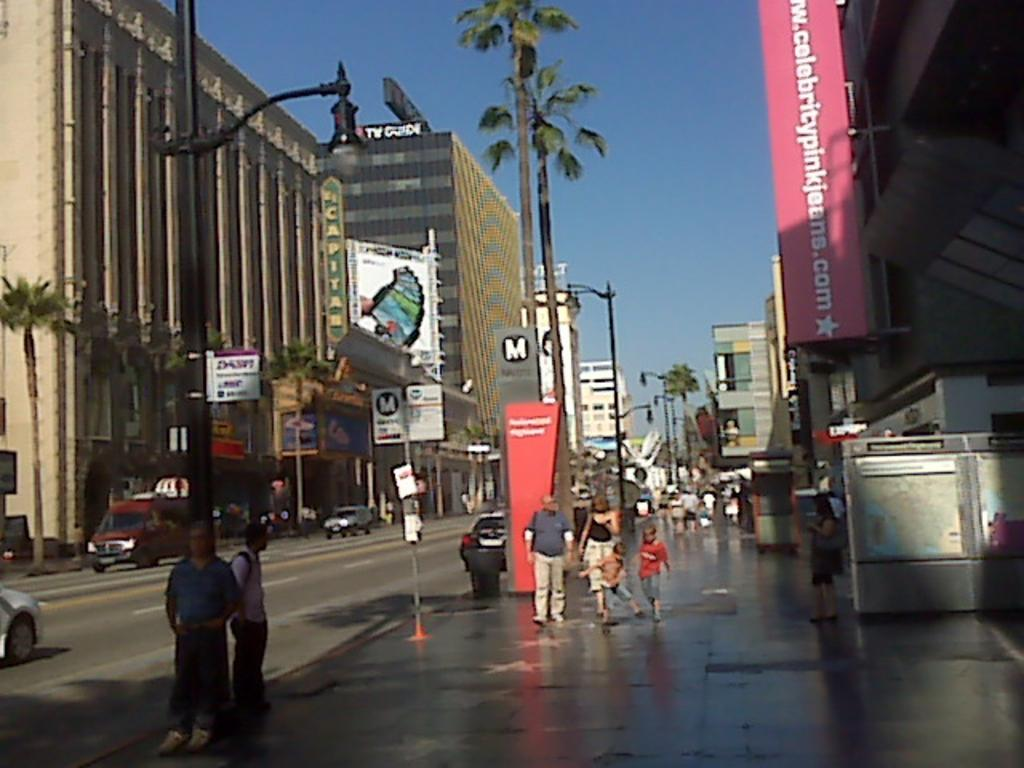<image>
Give a short and clear explanation of the subsequent image. A sidewalk with a building that has a banner for "www.celebritypinkjeans.com". 